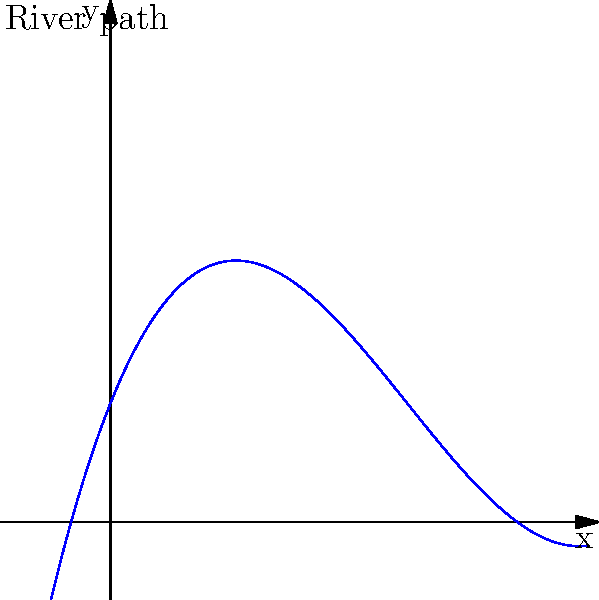As a traditional cartographer creating an artistic map of a winding river, you've decided to use a polynomial function to represent a section of the river's path. The curve is given by the function $f(x) = 0.2x^3 - 1.5x^2 + 2.5x + 1$. At which point along this curve does the river have the most pronounced bend, and what is the mathematical significance of this point? To find the point of the most pronounced bend in the river, we need to determine the point of maximum curvature. This occurs at the point where the second derivative of the function has its maximum absolute value. Let's solve this step-by-step:

1) First, find the first derivative of $f(x)$:
   $f'(x) = 0.6x^2 - 3x + 2.5$

2) Now, find the second derivative:
   $f''(x) = 1.2x - 3$

3) The point of maximum curvature occurs where $f''(x)$ has its maximum absolute value. Since $f''(x)$ is a linear function, its maximum absolute value will occur at one of the endpoints of our domain or where its derivative equals zero.

4) Set $f''(x) = 0$ and solve:
   $1.2x - 3 = 0$
   $1.2x = 3$
   $x = 2.5$

5) This x-value of 2.5 represents the point of inflection of our original function, where the curve changes from concave down to concave up (or vice versa).

6) The y-coordinate at this point can be found by plugging x = 2.5 into our original function:
   $f(2.5) = 0.2(2.5)^3 - 1.5(2.5)^2 + 2.5(2.5) + 1 = 2.8125$

Therefore, the point (2.5, 2.8125) represents the location of the most pronounced bend in the river. This point is mathematically significant because it's the inflection point of the curve, where the concavity changes.
Answer: (2.5, 2.8125); inflection point 